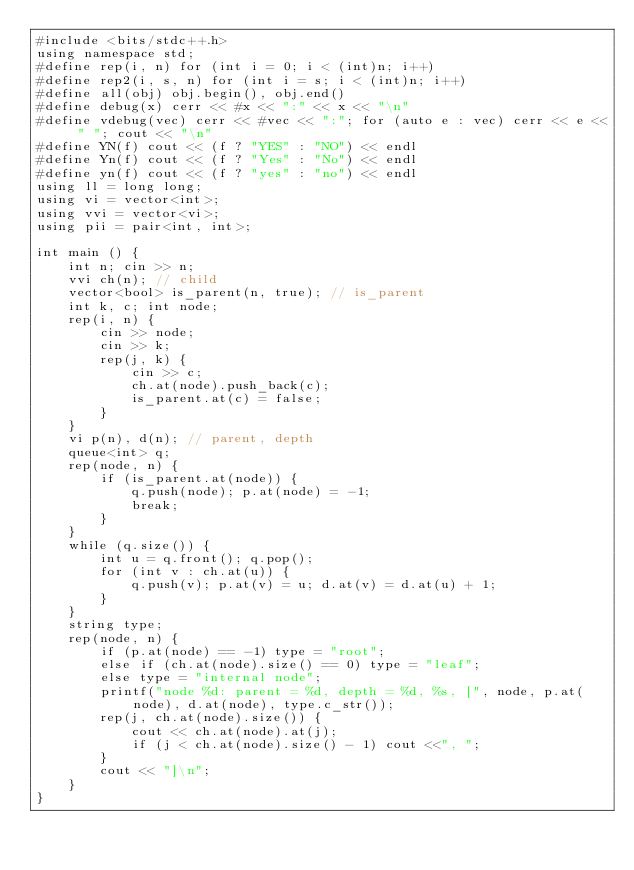<code> <loc_0><loc_0><loc_500><loc_500><_C++_>#include <bits/stdc++.h>
using namespace std;
#define rep(i, n) for (int i = 0; i < (int)n; i++)
#define rep2(i, s, n) for (int i = s; i < (int)n; i++)
#define all(obj) obj.begin(), obj.end()
#define debug(x) cerr << #x << ":" << x << "\n"
#define vdebug(vec) cerr << #vec << ":"; for (auto e : vec) cerr << e << " "; cout << "\n"
#define YN(f) cout << (f ? "YES" : "NO") << endl
#define Yn(f) cout << (f ? "Yes" : "No") << endl
#define yn(f) cout << (f ? "yes" : "no") << endl
using ll = long long;
using vi = vector<int>;
using vvi = vector<vi>;
using pii = pair<int, int>;

int main () {
	int n; cin >> n;
	vvi ch(n); // child
	vector<bool> is_parent(n, true); // is_parent
	int k, c; int node;
	rep(i, n) {
		cin >> node;
		cin >> k;
		rep(j, k) {
			cin >> c;
			ch.at(node).push_back(c);
			is_parent.at(c) = false;
		}
	}	
	vi p(n), d(n); // parent, depth
	queue<int> q;
	rep(node, n) {
		if (is_parent.at(node)) {
			q.push(node); p.at(node) = -1;
			break;
		}
	}
	while (q.size()) {
		int u = q.front(); q.pop();
		for (int v : ch.at(u)) {
			q.push(v); p.at(v) = u; d.at(v) = d.at(u) + 1;
		}
	}
	string type;
	rep(node, n) {
		if (p.at(node) == -1) type = "root";
		else if (ch.at(node).size() == 0) type = "leaf";
		else type = "internal node";
		printf("node %d: parent = %d, depth = %d, %s, [", node, p.at(node), d.at(node), type.c_str());
		rep(j, ch.at(node).size()) {
			cout << ch.at(node).at(j);
			if (j < ch.at(node).size() - 1) cout <<", ";
		}
		cout << "]\n";
	}
}
</code> 